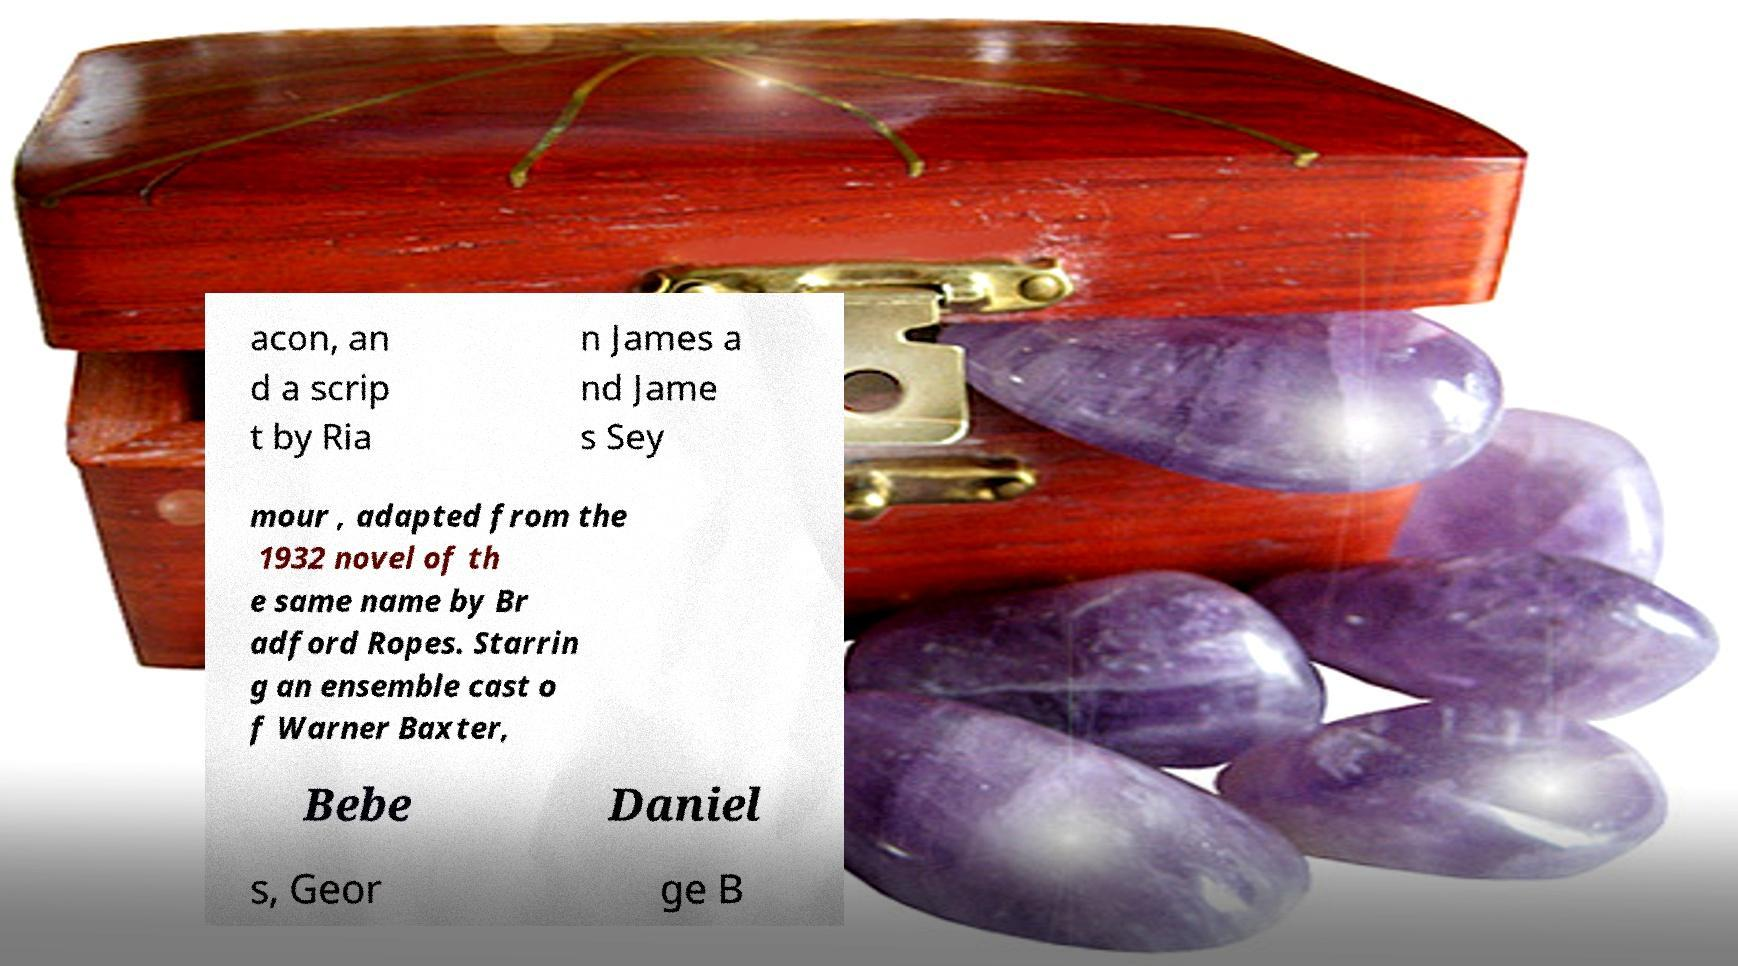What messages or text are displayed in this image? I need them in a readable, typed format. acon, an d a scrip t by Ria n James a nd Jame s Sey mour , adapted from the 1932 novel of th e same name by Br adford Ropes. Starrin g an ensemble cast o f Warner Baxter, Bebe Daniel s, Geor ge B 